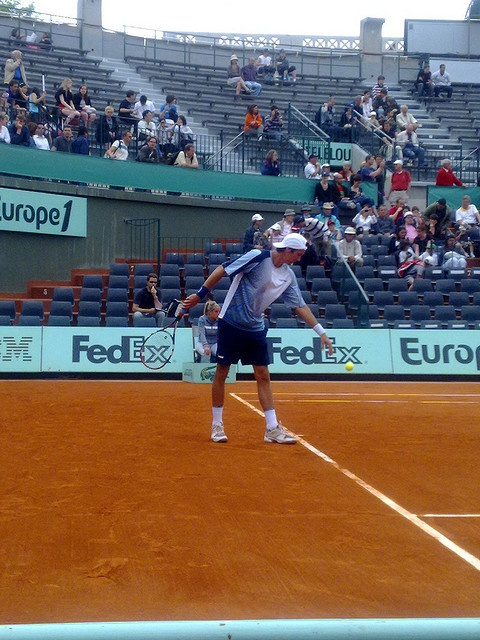Describe the objects in this image and their specific colors. I can see people in darkgray, black, navy, maroon, and gray tones, tennis racket in darkgray, lightblue, blue, and gray tones, people in darkgray, black, navy, and gray tones, people in darkgray and gray tones, and people in darkgray, navy, gray, and white tones in this image. 